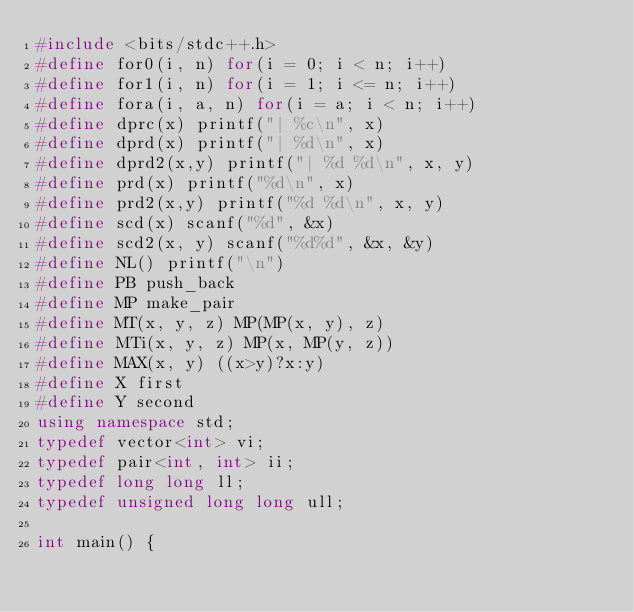<code> <loc_0><loc_0><loc_500><loc_500><_C++_>#include <bits/stdc++.h>
#define for0(i, n) for(i = 0; i < n; i++)
#define for1(i, n) for(i = 1; i <= n; i++)
#define fora(i, a, n) for(i = a; i < n; i++)
#define dprc(x) printf("| %c\n", x)
#define dprd(x) printf("| %d\n", x)
#define dprd2(x,y) printf("| %d %d\n", x, y)
#define prd(x) printf("%d\n", x)
#define prd2(x,y) printf("%d %d\n", x, y)
#define scd(x) scanf("%d", &x)
#define scd2(x, y) scanf("%d%d", &x, &y)
#define NL() printf("\n")
#define PB push_back
#define MP make_pair
#define MT(x, y, z) MP(MP(x, y), z)
#define MTi(x, y, z) MP(x, MP(y, z))
#define MAX(x, y) ((x>y)?x:y)
#define X first
#define Y second
using namespace std;
typedef vector<int> vi;
typedef pair<int, int> ii;
typedef long long ll;
typedef unsigned long long ull;

int main() {</code> 